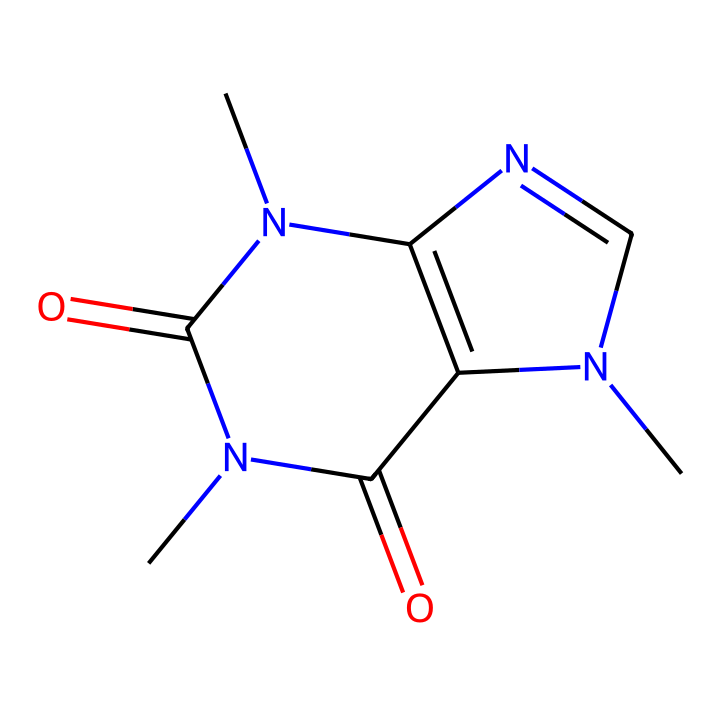What is the molecular formula of caffeine? To determine the molecular formula, count the number of each type of atom in the structure. In the given SMILES representation, there are 8 carbon (C) atoms, 10 hydrogen (H) atoms, 4 nitrogen (N) atoms, and 2 oxygen (O) atoms. Thus, the molecular formula is C8H10N4O2.
Answer: C8H10N4O2 How many nitrogen atoms are present in caffeine? Counting nitrogen atoms directly from the chemical structure or the SMILES, we find four nitrogen atoms present.
Answer: 4 What is the hybridization of the carbon atoms involved in the carbene feature of this molecule? In carbenes, the carbon atom typically has a valence of two and is sp2 hybridized. Analyzing the structure, the carbon within the carbene linkage is similar due to the presence of a double bond to nitrogen and can fulfill this characteristic.
Answer: sp2 What type of reaction might a carbene participate in due to its reactivity? Carbenes are highly reactive species that can initiate cyclopropanation, a specific reaction where they react with alkenes to form cyclopropane derivatives. This reactivity is due to their electron-deficient nature.
Answer: cyclopropanation What characteristic property makes a carbene different from other functional groups? Carbenes possess a neutral carbon atom with only six valence electrons, making them electron-deficient, which contrasts with the typical stable functional groups that have complete octets.
Answer: electron deficiency 